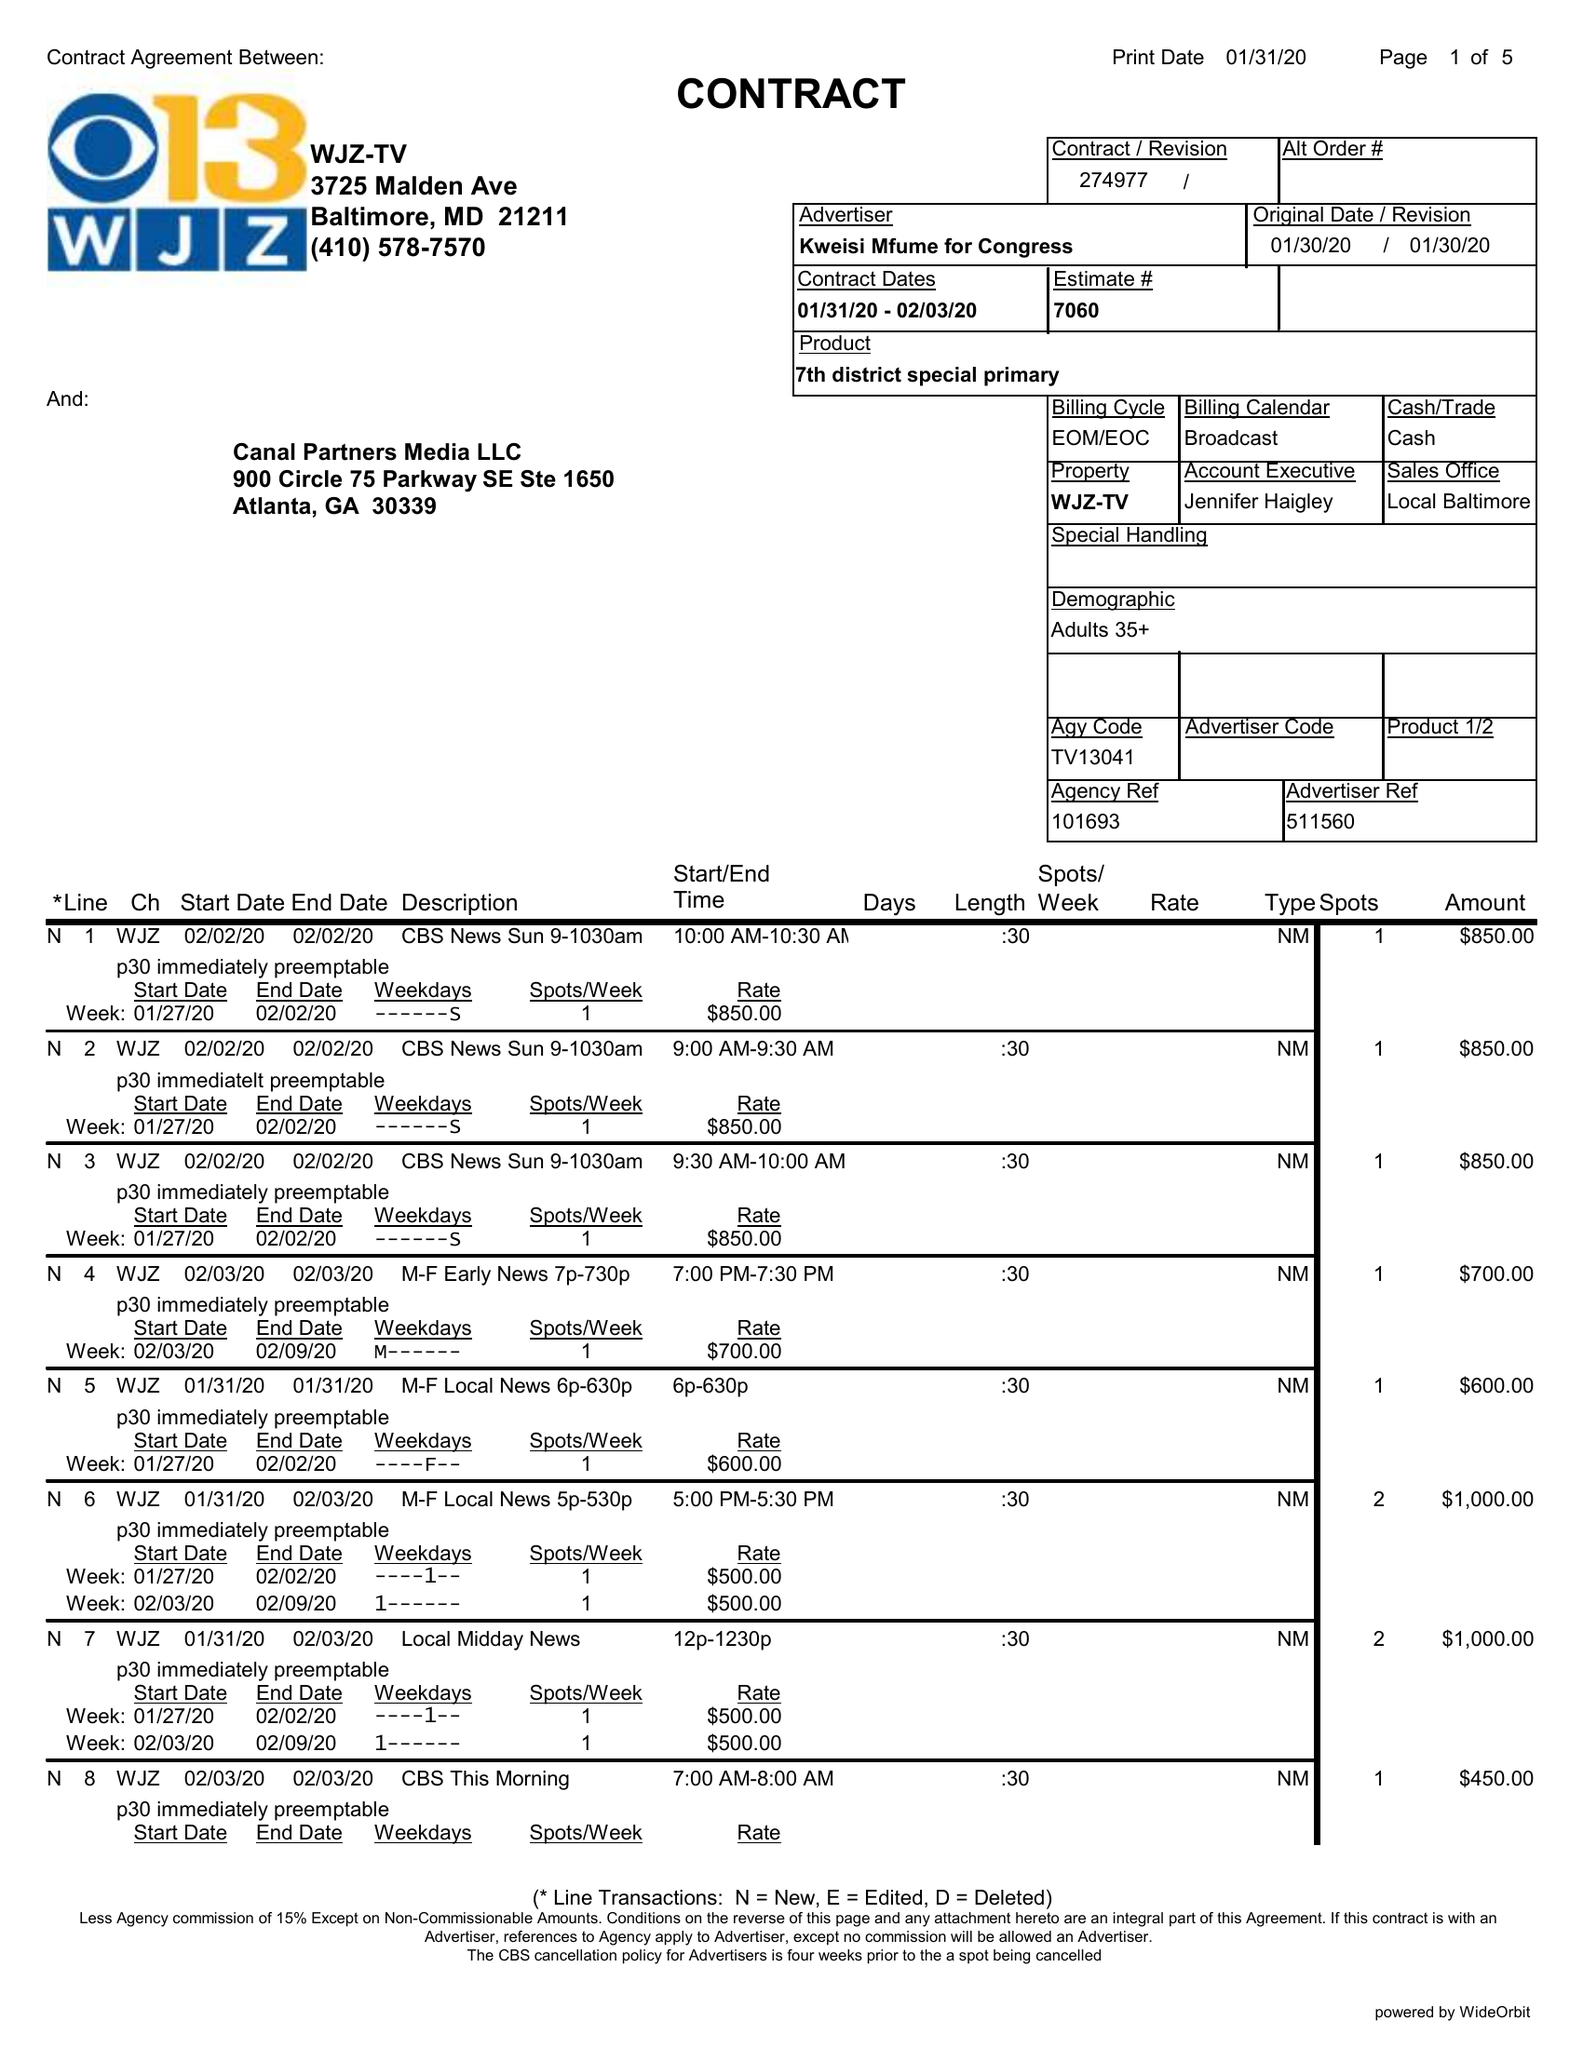What is the value for the gross_amount?
Answer the question using a single word or phrase. 11600.00 